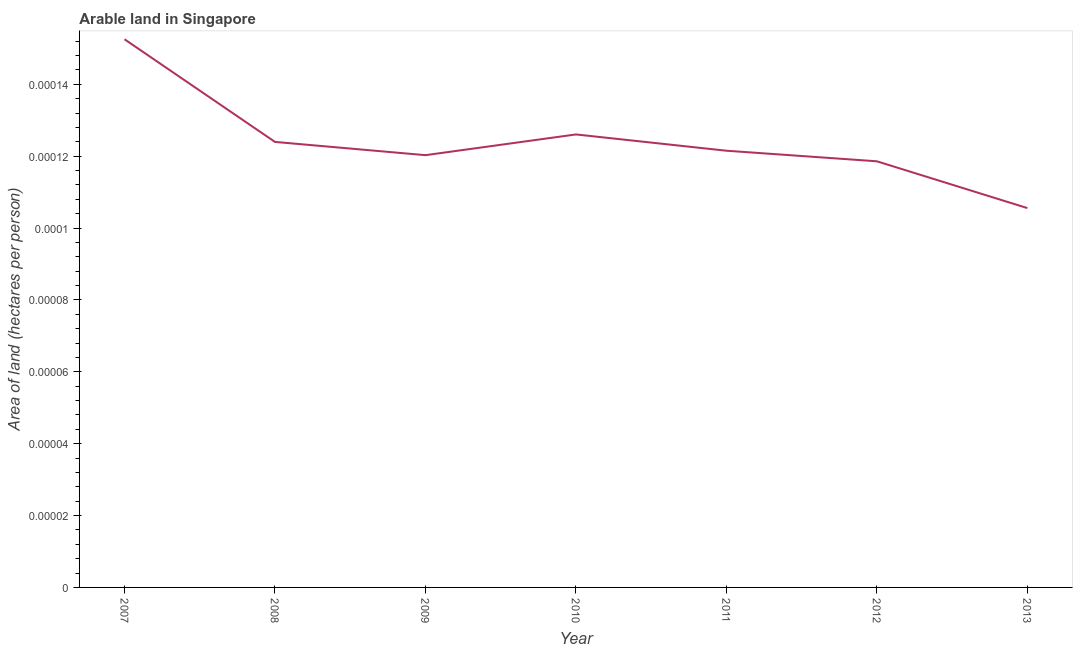What is the area of arable land in 2008?
Give a very brief answer. 0. Across all years, what is the maximum area of arable land?
Keep it short and to the point. 0. Across all years, what is the minimum area of arable land?
Keep it short and to the point. 0. In which year was the area of arable land maximum?
Your answer should be compact. 2007. In which year was the area of arable land minimum?
Provide a succinct answer. 2013. What is the sum of the area of arable land?
Ensure brevity in your answer.  0. What is the difference between the area of arable land in 2008 and 2011?
Provide a short and direct response. 2.447500814535986e-6. What is the average area of arable land per year?
Provide a succinct answer. 0. What is the median area of arable land?
Your answer should be compact. 0. What is the ratio of the area of arable land in 2009 to that in 2011?
Offer a terse response. 0.99. What is the difference between the highest and the second highest area of arable land?
Keep it short and to the point. 2.6485831307126003e-5. Is the sum of the area of arable land in 2009 and 2013 greater than the maximum area of arable land across all years?
Offer a terse response. Yes. What is the difference between the highest and the lowest area of arable land?
Keep it short and to the point. 4.6980780905053e-5. What is the difference between two consecutive major ticks on the Y-axis?
Offer a very short reply. 2e-5. Are the values on the major ticks of Y-axis written in scientific E-notation?
Your answer should be very brief. No. Does the graph contain any zero values?
Your response must be concise. No. What is the title of the graph?
Offer a terse response. Arable land in Singapore. What is the label or title of the Y-axis?
Ensure brevity in your answer.  Area of land (hectares per person). What is the Area of land (hectares per person) in 2007?
Make the answer very short. 0. What is the Area of land (hectares per person) of 2008?
Keep it short and to the point. 0. What is the Area of land (hectares per person) of 2009?
Your response must be concise. 0. What is the Area of land (hectares per person) of 2010?
Give a very brief answer. 0. What is the Area of land (hectares per person) in 2011?
Provide a short and direct response. 0. What is the Area of land (hectares per person) in 2012?
Offer a terse response. 0. What is the Area of land (hectares per person) of 2013?
Offer a very short reply. 0. What is the difference between the Area of land (hectares per person) in 2007 and 2008?
Provide a short and direct response. 3e-5. What is the difference between the Area of land (hectares per person) in 2007 and 2009?
Your response must be concise. 3e-5. What is the difference between the Area of land (hectares per person) in 2007 and 2010?
Offer a terse response. 3e-5. What is the difference between the Area of land (hectares per person) in 2007 and 2011?
Give a very brief answer. 3e-5. What is the difference between the Area of land (hectares per person) in 2007 and 2012?
Make the answer very short. 3e-5. What is the difference between the Area of land (hectares per person) in 2007 and 2013?
Ensure brevity in your answer.  5e-5. What is the difference between the Area of land (hectares per person) in 2008 and 2009?
Provide a succinct answer. 0. What is the difference between the Area of land (hectares per person) in 2008 and 2010?
Your response must be concise. -0. What is the difference between the Area of land (hectares per person) in 2008 and 2011?
Offer a terse response. 0. What is the difference between the Area of land (hectares per person) in 2008 and 2012?
Provide a succinct answer. 1e-5. What is the difference between the Area of land (hectares per person) in 2008 and 2013?
Your answer should be compact. 2e-5. What is the difference between the Area of land (hectares per person) in 2009 and 2010?
Your answer should be compact. -1e-5. What is the difference between the Area of land (hectares per person) in 2009 and 2011?
Your answer should be very brief. -0. What is the difference between the Area of land (hectares per person) in 2009 and 2013?
Give a very brief answer. 1e-5. What is the difference between the Area of land (hectares per person) in 2010 and 2012?
Give a very brief answer. 1e-5. What is the difference between the Area of land (hectares per person) in 2010 and 2013?
Give a very brief answer. 2e-5. What is the difference between the Area of land (hectares per person) in 2011 and 2012?
Offer a terse response. 0. What is the difference between the Area of land (hectares per person) in 2011 and 2013?
Provide a succinct answer. 2e-5. What is the difference between the Area of land (hectares per person) in 2012 and 2013?
Offer a very short reply. 1e-5. What is the ratio of the Area of land (hectares per person) in 2007 to that in 2008?
Your answer should be very brief. 1.23. What is the ratio of the Area of land (hectares per person) in 2007 to that in 2009?
Your answer should be very brief. 1.27. What is the ratio of the Area of land (hectares per person) in 2007 to that in 2010?
Provide a succinct answer. 1.21. What is the ratio of the Area of land (hectares per person) in 2007 to that in 2011?
Your answer should be very brief. 1.25. What is the ratio of the Area of land (hectares per person) in 2007 to that in 2012?
Keep it short and to the point. 1.29. What is the ratio of the Area of land (hectares per person) in 2007 to that in 2013?
Provide a short and direct response. 1.45. What is the ratio of the Area of land (hectares per person) in 2008 to that in 2009?
Offer a terse response. 1.03. What is the ratio of the Area of land (hectares per person) in 2008 to that in 2012?
Ensure brevity in your answer.  1.04. What is the ratio of the Area of land (hectares per person) in 2008 to that in 2013?
Offer a very short reply. 1.17. What is the ratio of the Area of land (hectares per person) in 2009 to that in 2010?
Your answer should be compact. 0.95. What is the ratio of the Area of land (hectares per person) in 2009 to that in 2011?
Your answer should be very brief. 0.99. What is the ratio of the Area of land (hectares per person) in 2009 to that in 2013?
Provide a short and direct response. 1.14. What is the ratio of the Area of land (hectares per person) in 2010 to that in 2011?
Your response must be concise. 1.04. What is the ratio of the Area of land (hectares per person) in 2010 to that in 2012?
Your answer should be compact. 1.06. What is the ratio of the Area of land (hectares per person) in 2010 to that in 2013?
Give a very brief answer. 1.19. What is the ratio of the Area of land (hectares per person) in 2011 to that in 2013?
Ensure brevity in your answer.  1.15. What is the ratio of the Area of land (hectares per person) in 2012 to that in 2013?
Keep it short and to the point. 1.12. 